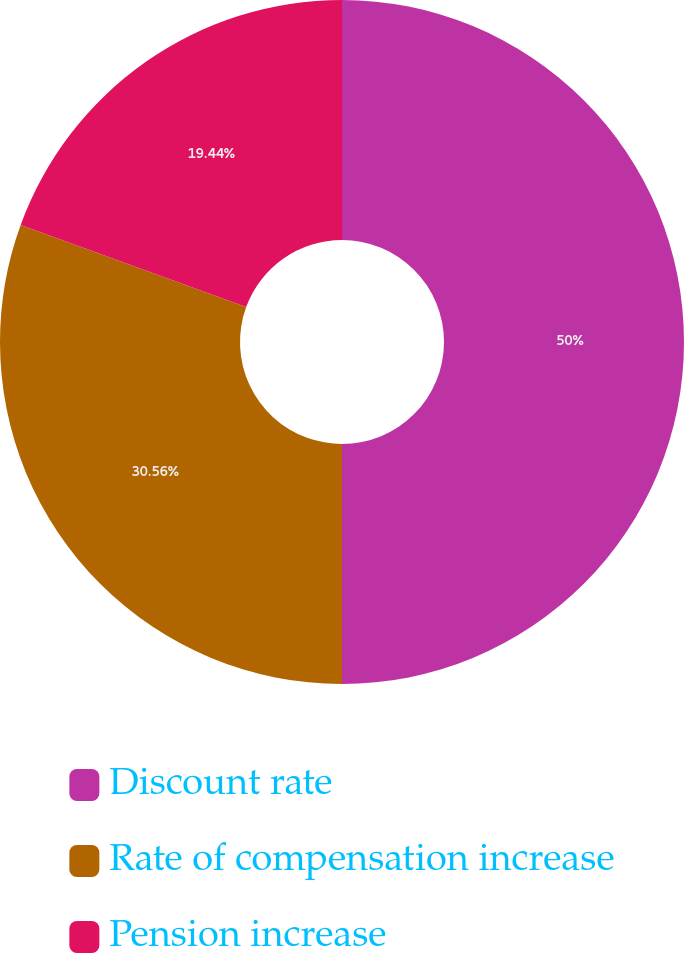Convert chart to OTSL. <chart><loc_0><loc_0><loc_500><loc_500><pie_chart><fcel>Discount rate<fcel>Rate of compensation increase<fcel>Pension increase<nl><fcel>50.0%<fcel>30.56%<fcel>19.44%<nl></chart> 